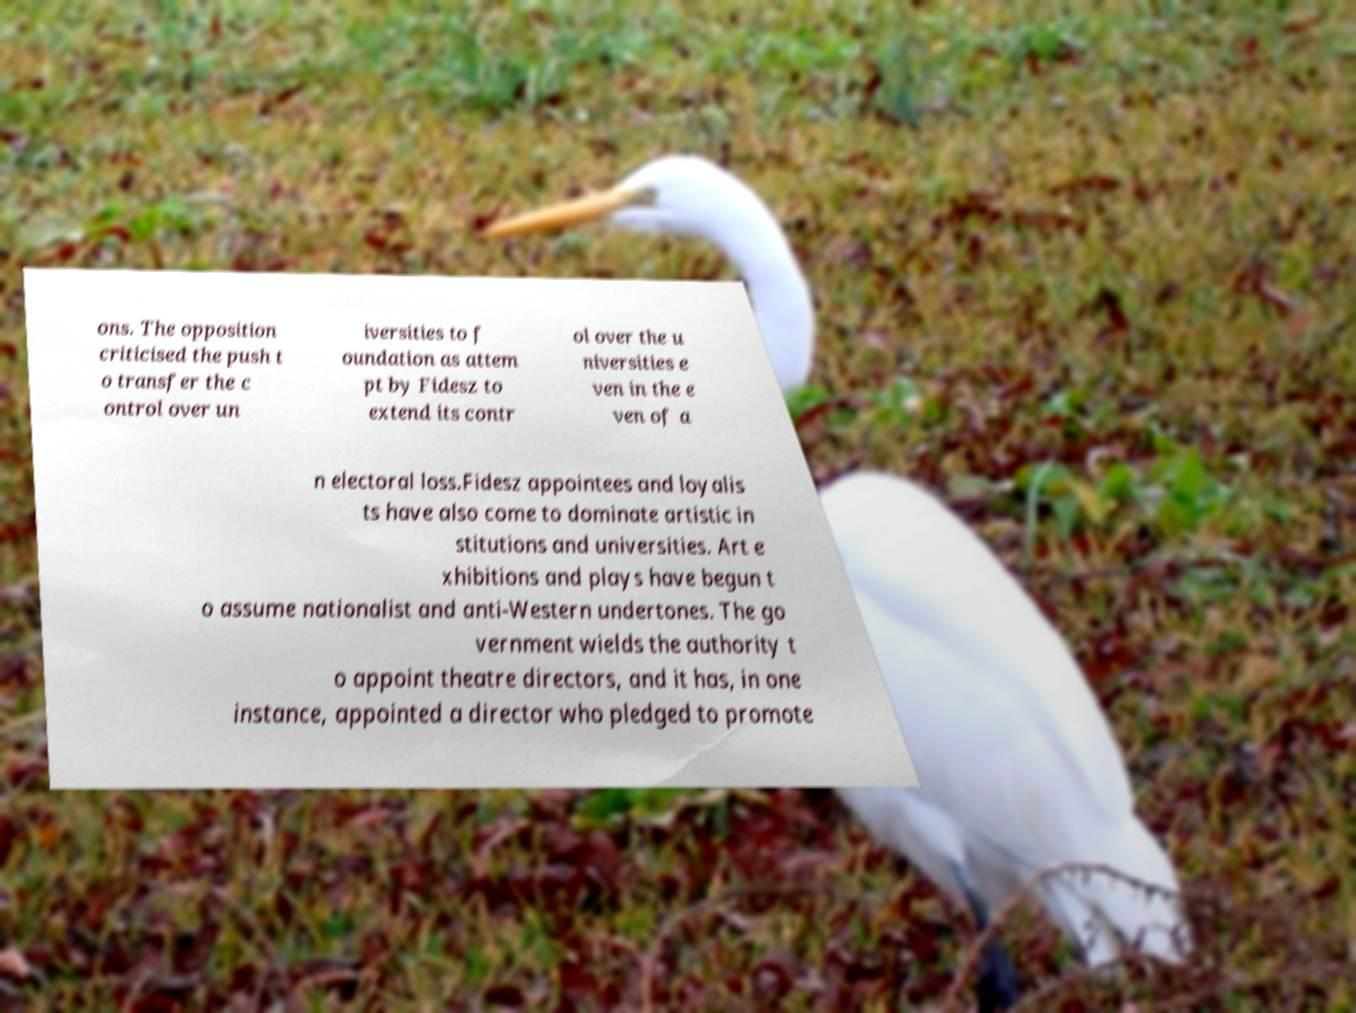Please read and relay the text visible in this image. What does it say? ons. The opposition criticised the push t o transfer the c ontrol over un iversities to f oundation as attem pt by Fidesz to extend its contr ol over the u niversities e ven in the e ven of a n electoral loss.Fidesz appointees and loyalis ts have also come to dominate artistic in stitutions and universities. Art e xhibitions and plays have begun t o assume nationalist and anti-Western undertones. The go vernment wields the authority t o appoint theatre directors, and it has, in one instance, appointed a director who pledged to promote 